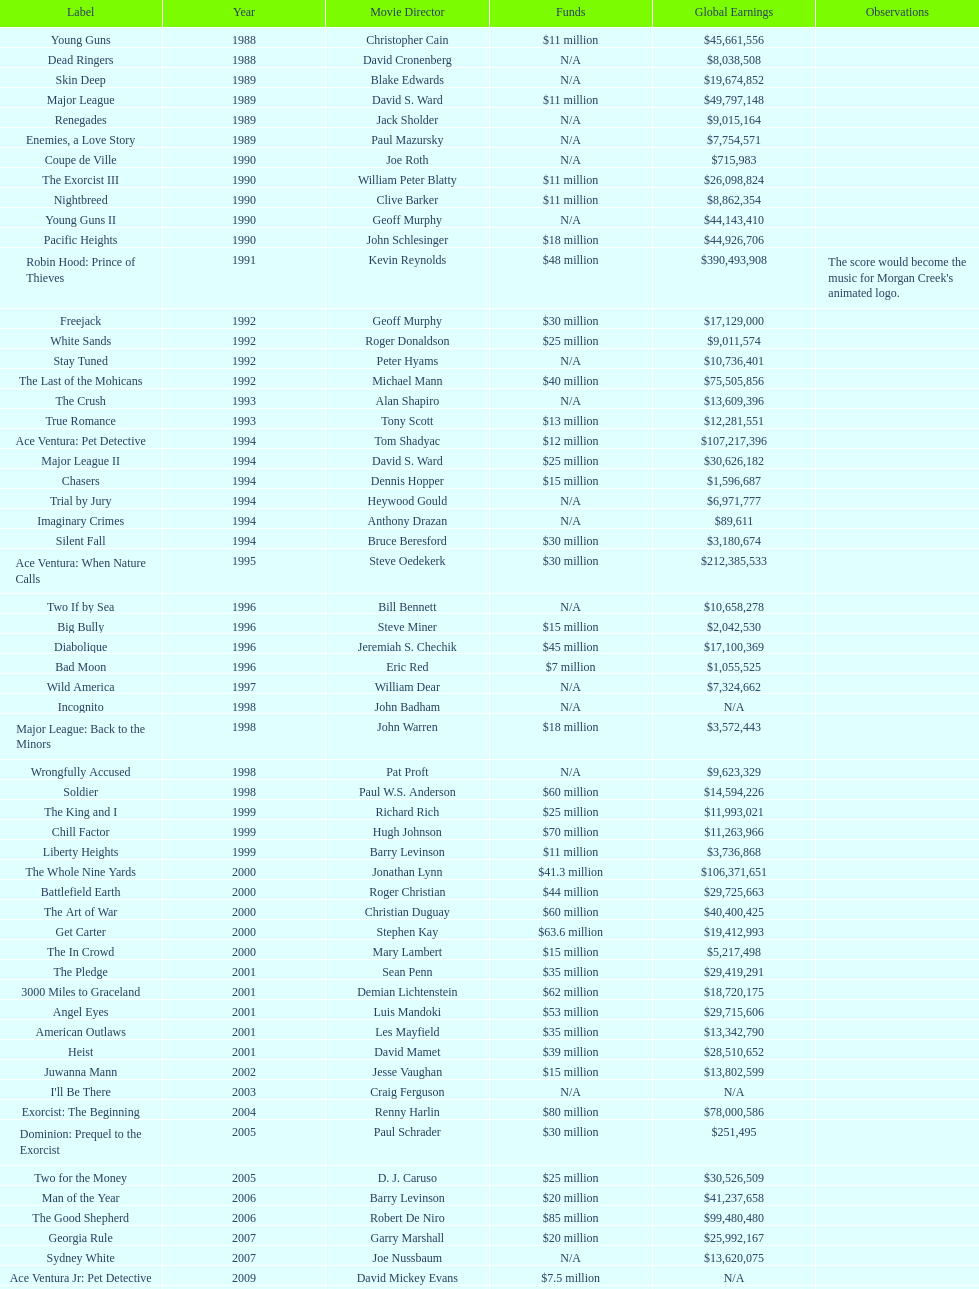What movie was made immediately before the pledge? The In Crowd. 